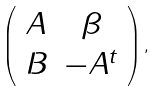<formula> <loc_0><loc_0><loc_500><loc_500>\left ( \begin{array} { c c } A & \beta \\ B & - A ^ { t } \end{array} \right ) ,</formula> 